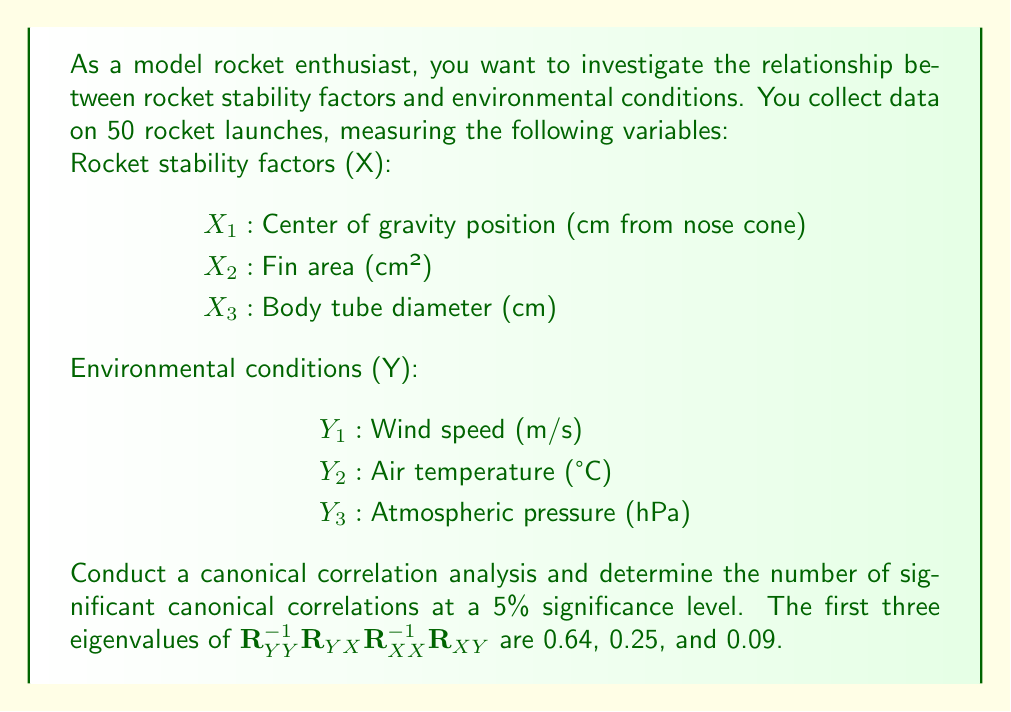Help me with this question. To determine the number of significant canonical correlations, we need to follow these steps:

1) First, recall that the eigenvalues of $\mathbf{R}_{YY}^{-1}\mathbf{R}_{YX}\mathbf{R}_{XX}^{-1}\mathbf{R}_{XY}$ are the squared canonical correlations.

2) Convert the given eigenvalues to canonical correlations:
   $r_1 = \sqrt{0.64} = 0.80$
   $r_2 = \sqrt{0.25} = 0.50$
   $r_3 = \sqrt{0.09} = 0.30$

3) We need to test the significance of these correlations using Wilks' lambda test. The test statistic is:

   $$\Lambda_k = \prod_{i=k}^p (1 - r_i^2)$$

   where $p$ is the number of canonical correlations (3 in this case).

4) For each $k$ from 1 to 3, we calculate:

   $\Lambda_1 = (1 - 0.80^2)(1 - 0.50^2)(1 - 0.30^2) = 0.2925$
   $\Lambda_2 = (1 - 0.50^2)(1 - 0.30^2) = 0.8125$
   $\Lambda_3 = (1 - 0.30^2) = 0.91$

5) The test statistic follows a chi-square distribution:

   $$\chi^2 = -[n - 1 - \frac{1}{2}(p + q + 1)]\ln(\Lambda_k)$$

   where $n$ is the sample size (50), $p$ is the number of X variables (3), and $q$ is the number of Y variables (3).

6) Calculate the chi-square statistic for each $k$:

   $\chi^2_1 = -[50 - 1 - \frac{1}{2}(3 + 3 + 1)]\ln(0.2925) = 55.76$
   $\chi^2_2 = -[50 - 1 - \frac{1}{2}(3 + 3 + 1)]\ln(0.8125) = 9.32$
   $\chi^2_3 = -[50 - 1 - \frac{1}{2}(3 + 3 + 1)]\ln(0.91) = 4.18$

7) The degrees of freedom for each test are:

   $df_k = (p - k + 1)(q - k + 1)$

   $df_1 = 9$, $df_2 = 4$, $df_3 = 1$

8) Compare each chi-square value to the critical value at 5% significance level:

   $\chi^2_{0.05,9} = 16.92$
   $\chi^2_{0.05,4} = 9.49$
   $\chi^2_{0.05,1} = 3.84$

9) The number of significant canonical correlations is determined by how many tests reject the null hypothesis (i.e., have a chi-square value greater than the critical value).
Answer: There are 2 significant canonical correlations at the 5% significance level. The first two tests ($\chi^2_1 = 55.76 > 16.92$ and $\chi^2_2 = 9.32 > 9.49$) reject the null hypothesis, while the third test ($\chi^2_3 = 4.18 < 3.84$) fails to reject the null hypothesis. 